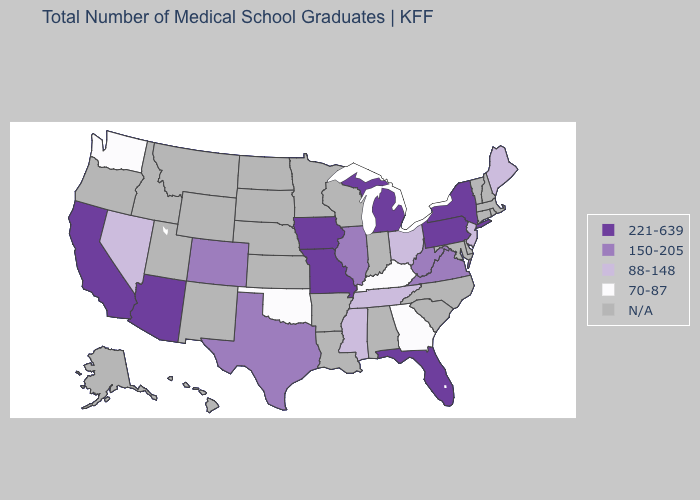Name the states that have a value in the range N/A?
Answer briefly. Alabama, Alaska, Arkansas, Connecticut, Delaware, Hawaii, Idaho, Indiana, Kansas, Louisiana, Maryland, Massachusetts, Minnesota, Montana, Nebraska, New Hampshire, New Mexico, North Carolina, North Dakota, Oregon, Rhode Island, South Carolina, South Dakota, Utah, Vermont, Wisconsin, Wyoming. Does Georgia have the lowest value in the USA?
Answer briefly. Yes. Among the states that border Alabama , which have the highest value?
Concise answer only. Florida. Among the states that border Pennsylvania , does West Virginia have the highest value?
Quick response, please. No. Which states have the highest value in the USA?
Give a very brief answer. Arizona, California, Florida, Iowa, Michigan, Missouri, New York, Pennsylvania. What is the value of Maine?
Give a very brief answer. 88-148. Name the states that have a value in the range 150-205?
Answer briefly. Colorado, Illinois, Texas, Virginia, West Virginia. Among the states that border Virginia , which have the highest value?
Answer briefly. West Virginia. What is the value of Oregon?
Quick response, please. N/A. Among the states that border Alabama , does Georgia have the highest value?
Keep it brief. No. What is the highest value in the West ?
Answer briefly. 221-639. Does Pennsylvania have the highest value in the USA?
Write a very short answer. Yes. What is the lowest value in the USA?
Quick response, please. 70-87. Among the states that border Colorado , does Oklahoma have the highest value?
Keep it brief. No. Name the states that have a value in the range 70-87?
Keep it brief. Georgia, Kentucky, Oklahoma, Washington. 